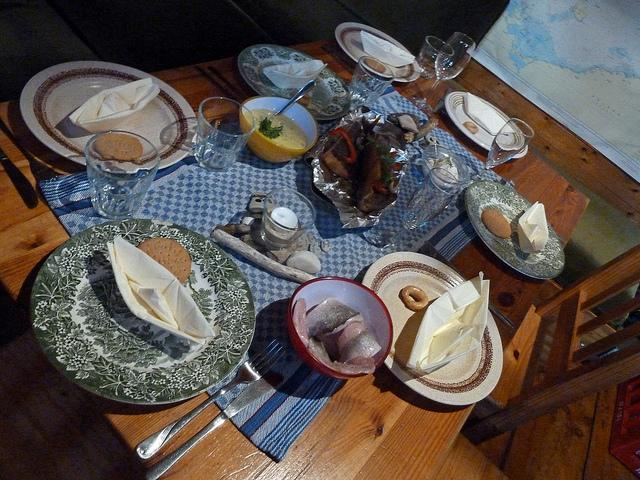What are the napkins folded to look like? Please explain your reasoning. boats. The napkin is a boat. 